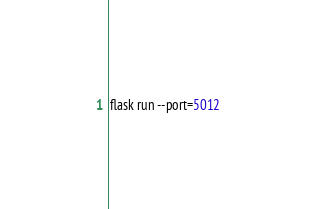<code> <loc_0><loc_0><loc_500><loc_500><_Bash_>flask run --port=5012</code> 